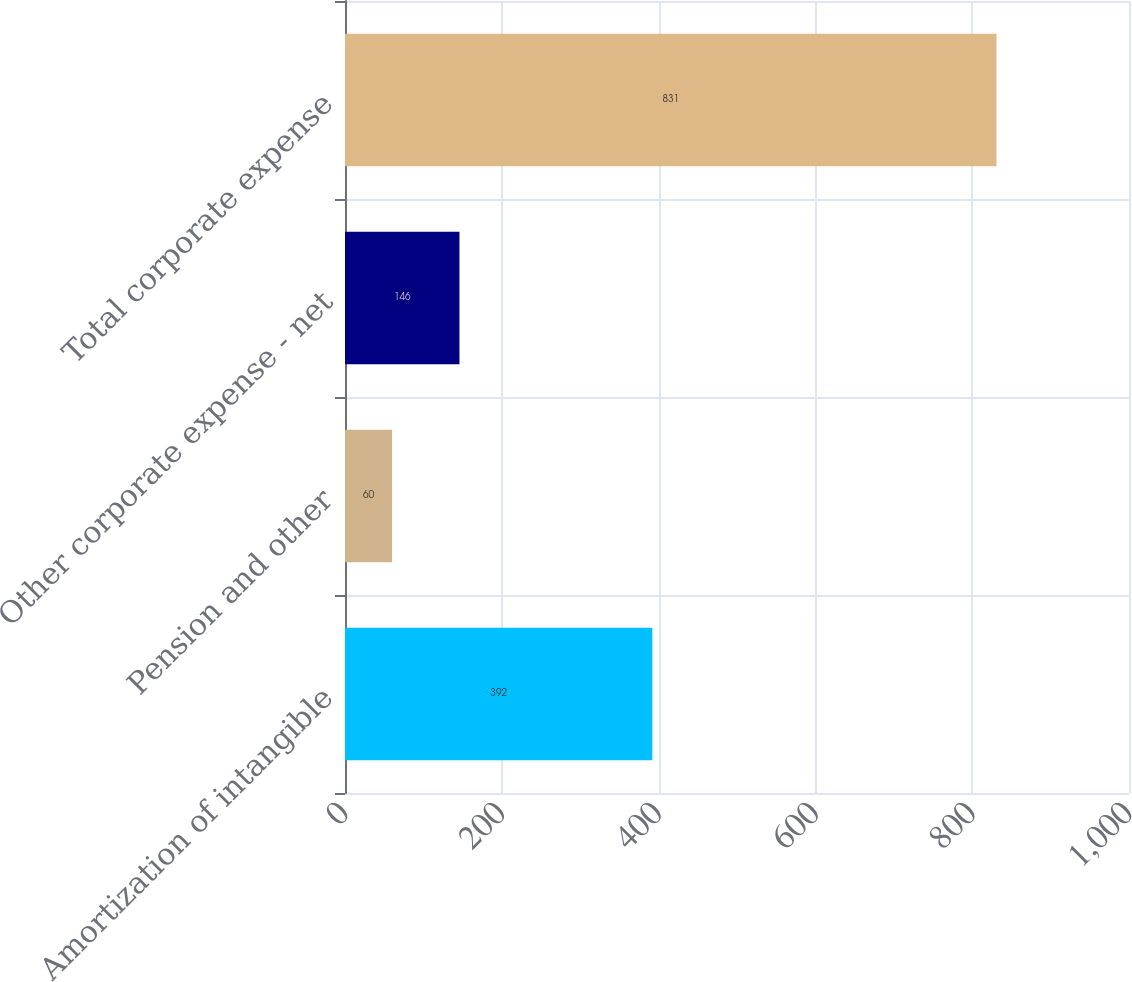Convert chart to OTSL. <chart><loc_0><loc_0><loc_500><loc_500><bar_chart><fcel>Amortization of intangible<fcel>Pension and other<fcel>Other corporate expense - net<fcel>Total corporate expense<nl><fcel>392<fcel>60<fcel>146<fcel>831<nl></chart> 